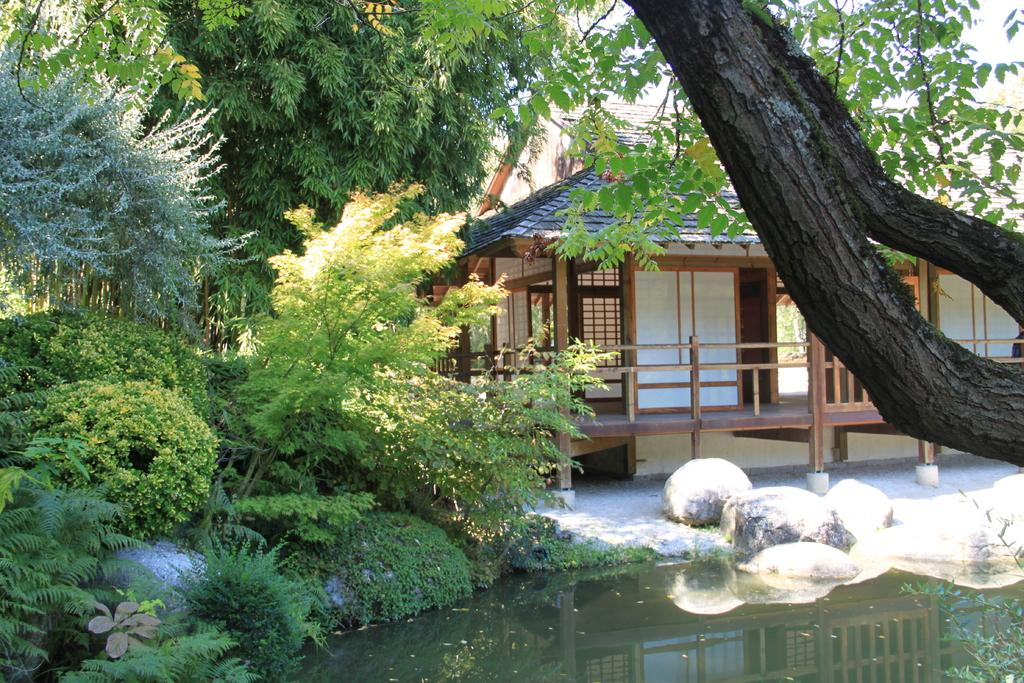What is located in the front of the image? There is a pond in the front of the image. What type of vegetation can be seen in the image? There are plants in the image. Where are the trees located in the image? The trees are on the left side of the image. What structure is visible behind the pond? There is a home visible behind the pond. What interest does the uncle have in the pond in the image? There is no mention of an uncle or any interests in the image. The image only shows a pond, plants, trees, and a home. 